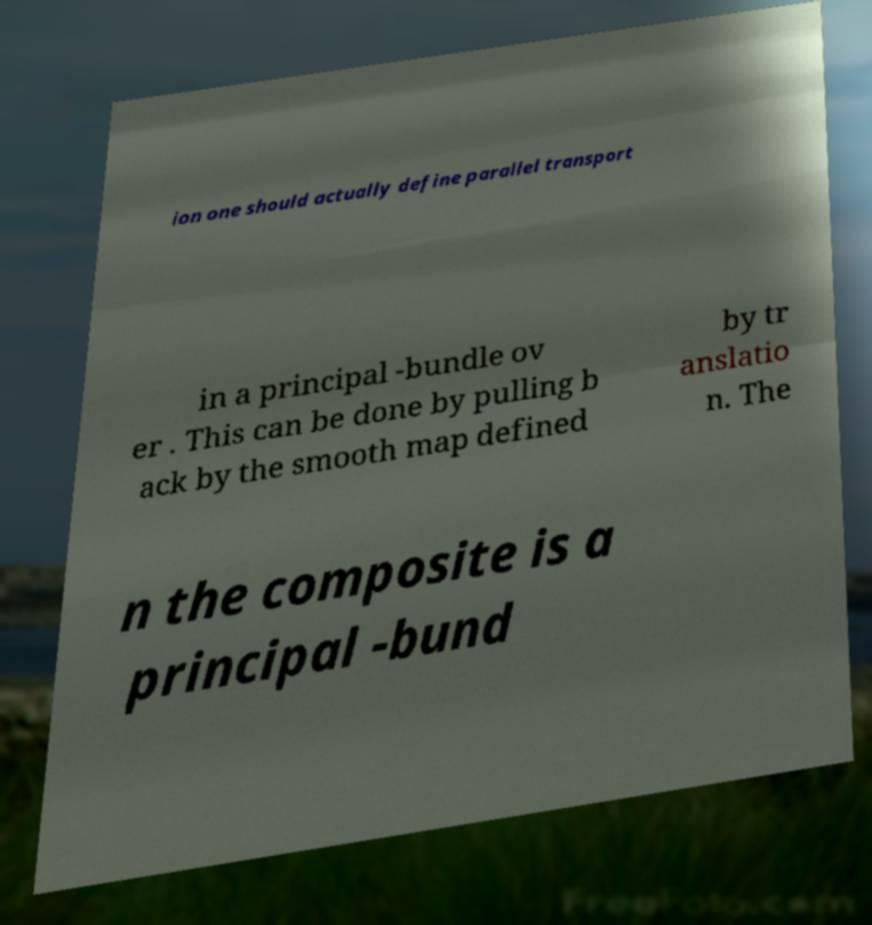Please identify and transcribe the text found in this image. ion one should actually define parallel transport in a principal -bundle ov er . This can be done by pulling b ack by the smooth map defined by tr anslatio n. The n the composite is a principal -bund 